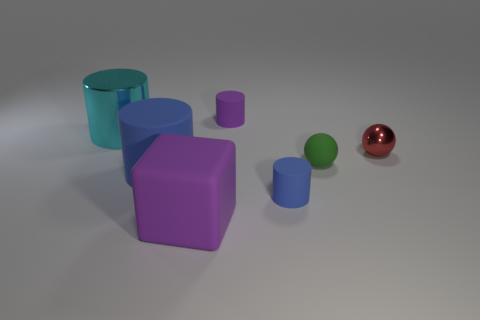What material is the small object that is the same color as the big block?
Give a very brief answer. Rubber. What is the size of the cylinder that is the same color as the block?
Your answer should be compact. Small. Does the small cylinder that is in front of the red shiny ball have the same material as the purple thing that is in front of the red metal ball?
Keep it short and to the point. Yes. What is the shape of the rubber thing that is behind the tiny blue rubber cylinder and to the right of the tiny purple matte cylinder?
Ensure brevity in your answer.  Sphere. Are there any other things that are the same material as the large cyan thing?
Provide a short and direct response. Yes. What is the small thing that is both behind the large blue thing and in front of the tiny red metallic ball made of?
Offer a terse response. Rubber. There is a small green thing that is made of the same material as the purple cube; what shape is it?
Your answer should be compact. Sphere. Are there any other things of the same color as the small shiny thing?
Your answer should be compact. No. Is the number of matte cylinders on the right side of the big matte cube greater than the number of purple cubes?
Your answer should be very brief. Yes. What is the material of the big blue cylinder?
Make the answer very short. Rubber. 